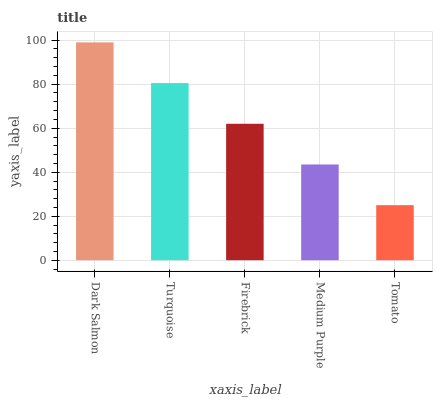Is Turquoise the minimum?
Answer yes or no. No. Is Turquoise the maximum?
Answer yes or no. No. Is Dark Salmon greater than Turquoise?
Answer yes or no. Yes. Is Turquoise less than Dark Salmon?
Answer yes or no. Yes. Is Turquoise greater than Dark Salmon?
Answer yes or no. No. Is Dark Salmon less than Turquoise?
Answer yes or no. No. Is Firebrick the high median?
Answer yes or no. Yes. Is Firebrick the low median?
Answer yes or no. Yes. Is Dark Salmon the high median?
Answer yes or no. No. Is Turquoise the low median?
Answer yes or no. No. 